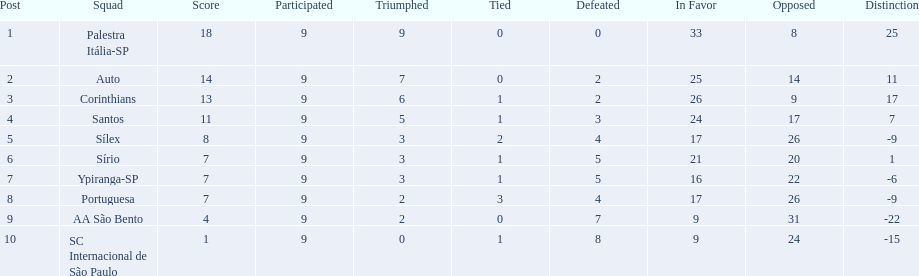How many points were scored by the teams? 18, 14, 13, 11, 8, 7, 7, 7, 4, 1. What team scored 13 points? Corinthians. 